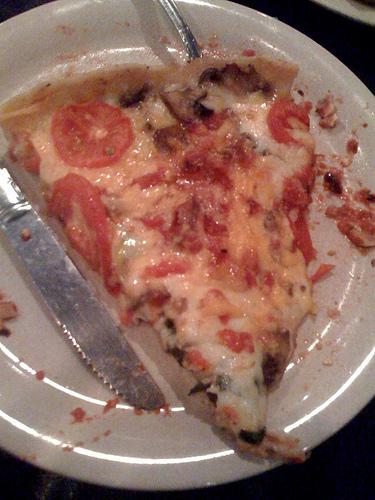What is on the plate next to the pizza?
Write a very short answer. Knife. Has this food been cooked?
Short answer required. Yes. Does the pizza look appetizing?
Short answer required. No. 